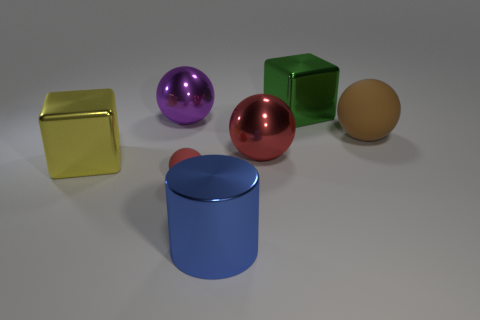What can this arrangement of objects tell us about the light source in this setup? The shadows and highlights suggest a light source located above and slightly to the right of the objects. This lighting creates soft shadows on the opposite side of each object and specular highlights which indicate the reflective properties of the materials.  Based on the reflections and space, what can we infer about the environment surrounding these objects? The reflections on the surfaces suggest that the objects are placed in an enclosed space with a neutral-colored background. There's no indication of an outdoor setting or additional objects nearby as there are no distinct reflections or colors that would hint at a complex environment. 